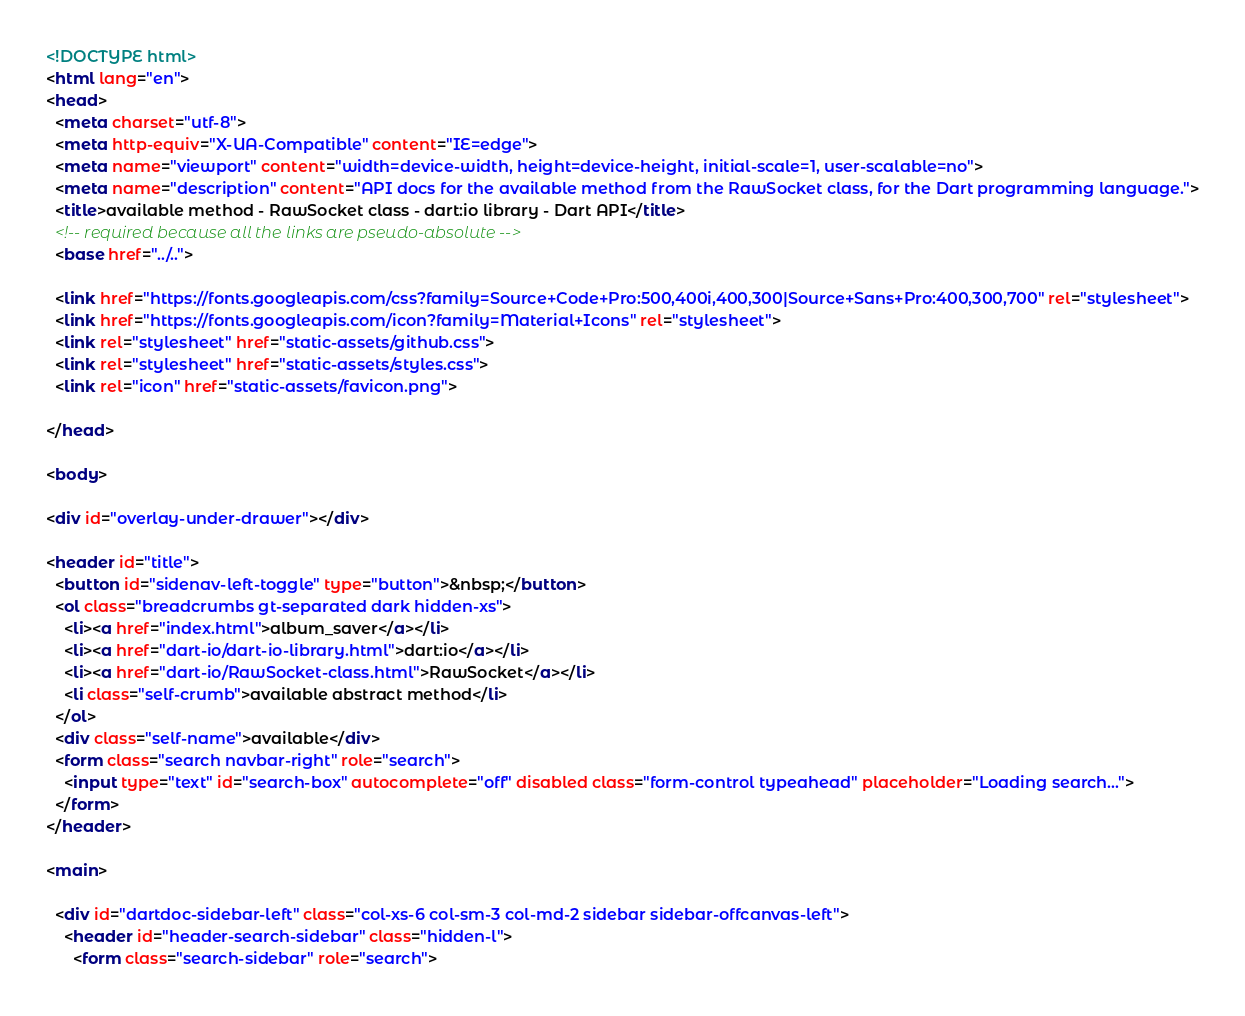Convert code to text. <code><loc_0><loc_0><loc_500><loc_500><_HTML_><!DOCTYPE html>
<html lang="en">
<head>
  <meta charset="utf-8">
  <meta http-equiv="X-UA-Compatible" content="IE=edge">
  <meta name="viewport" content="width=device-width, height=device-height, initial-scale=1, user-scalable=no">
  <meta name="description" content="API docs for the available method from the RawSocket class, for the Dart programming language.">
  <title>available method - RawSocket class - dart:io library - Dart API</title>
  <!-- required because all the links are pseudo-absolute -->
  <base href="../..">

  <link href="https://fonts.googleapis.com/css?family=Source+Code+Pro:500,400i,400,300|Source+Sans+Pro:400,300,700" rel="stylesheet">
  <link href="https://fonts.googleapis.com/icon?family=Material+Icons" rel="stylesheet">
  <link rel="stylesheet" href="static-assets/github.css">
  <link rel="stylesheet" href="static-assets/styles.css">
  <link rel="icon" href="static-assets/favicon.png">
  
</head>

<body>

<div id="overlay-under-drawer"></div>

<header id="title">
  <button id="sidenav-left-toggle" type="button">&nbsp;</button>
  <ol class="breadcrumbs gt-separated dark hidden-xs">
    <li><a href="index.html">album_saver</a></li>
    <li><a href="dart-io/dart-io-library.html">dart:io</a></li>
    <li><a href="dart-io/RawSocket-class.html">RawSocket</a></li>
    <li class="self-crumb">available abstract method</li>
  </ol>
  <div class="self-name">available</div>
  <form class="search navbar-right" role="search">
    <input type="text" id="search-box" autocomplete="off" disabled class="form-control typeahead" placeholder="Loading search...">
  </form>
</header>

<main>

  <div id="dartdoc-sidebar-left" class="col-xs-6 col-sm-3 col-md-2 sidebar sidebar-offcanvas-left">
    <header id="header-search-sidebar" class="hidden-l">
      <form class="search-sidebar" role="search"></code> 